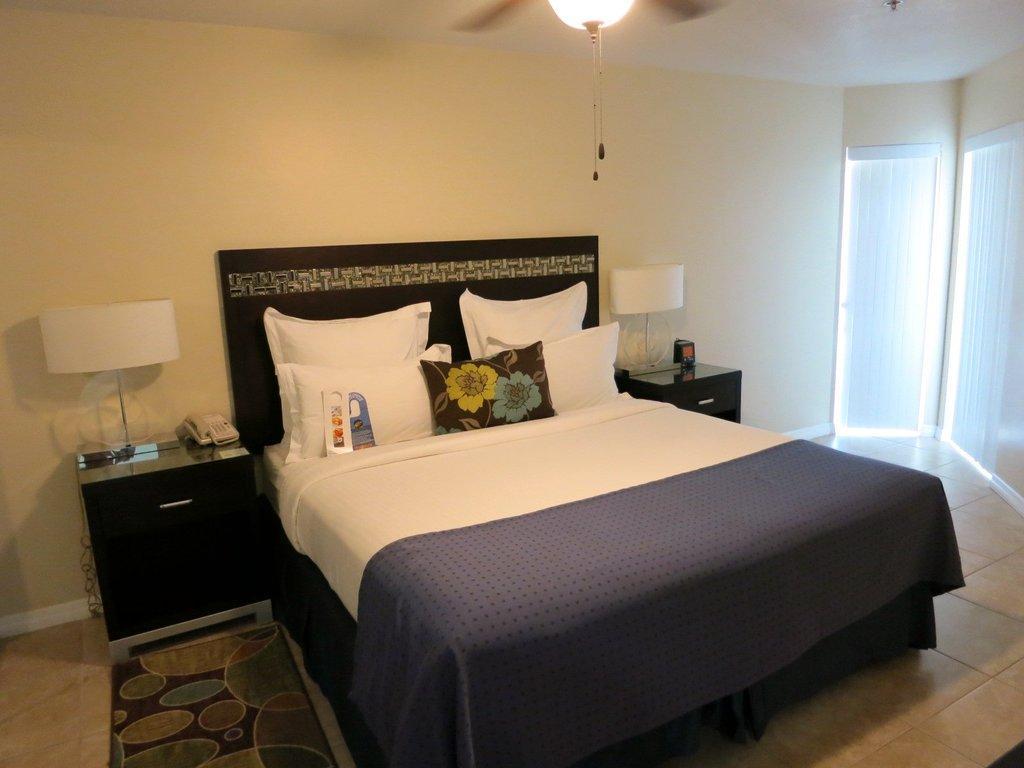Describe this image in one or two sentences. In this image we can see pillows, bed sheets on the bed on the floor and there are lamps, telephone and objects on the tables beside the bed. We can see wall, doors and light on the ceiling. 